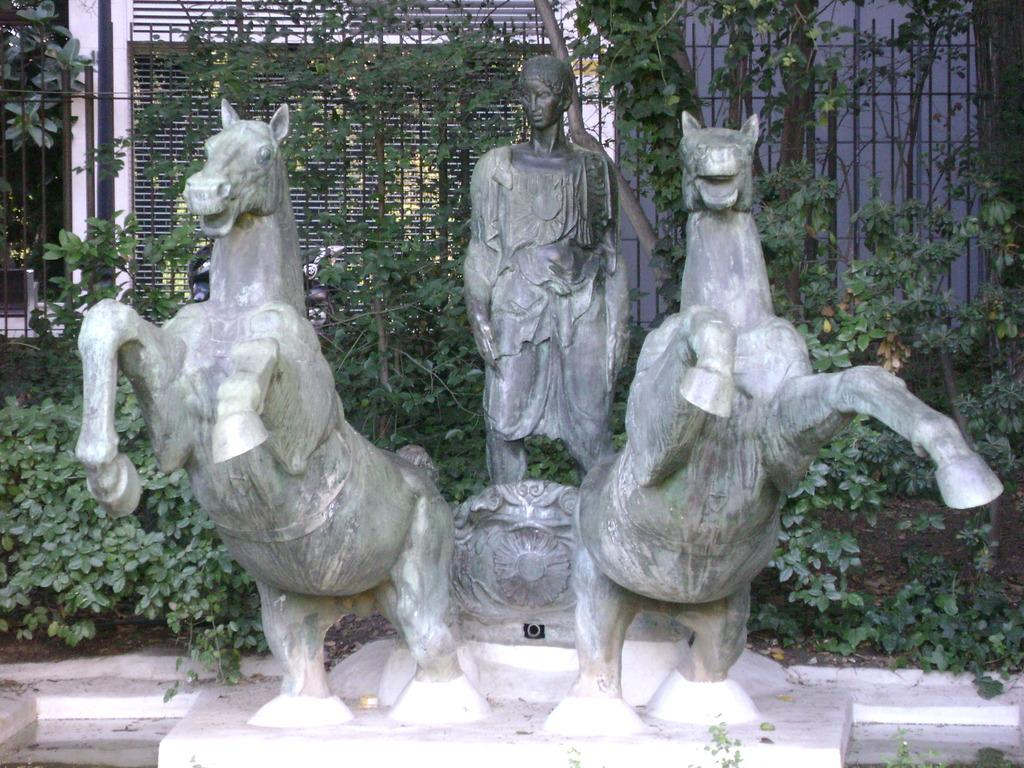What subjects are depicted in the sculptures in the image? There are sculptures of a person and two horses in the image. What type of vegetation can be seen in the image? Plants are visible in the image. What architectural feature is present in the image? Iron grilles are present in the image. What type of structure is visible in the image? There is a building visible in the image. What type of ornament is being used by the writer in the image? There is no writer or ornament present in the image. What type of linen is draped over the sculptures in the image? There is no linen present in the image; the sculptures are made of a solid material. 